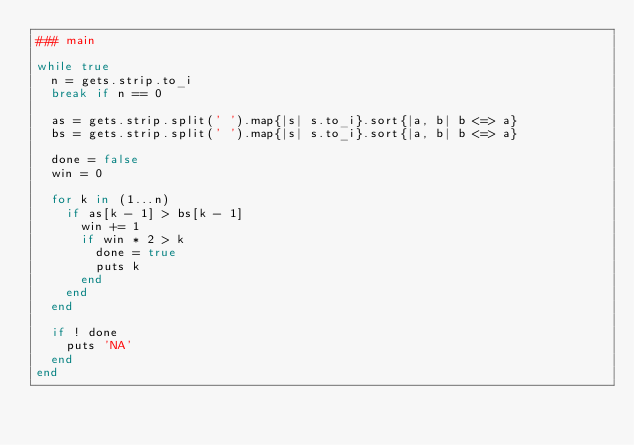<code> <loc_0><loc_0><loc_500><loc_500><_Ruby_>### main

while true
  n = gets.strip.to_i
  break if n == 0

  as = gets.strip.split(' ').map{|s| s.to_i}.sort{|a, b| b <=> a}
  bs = gets.strip.split(' ').map{|s| s.to_i}.sort{|a, b| b <=> a}

  done = false
  win = 0

  for k in (1...n)
    if as[k - 1] > bs[k - 1]
      win += 1
      if win * 2 > k
        done = true
        puts k
      end
    end
  end

  if ! done
    puts 'NA'
  end
end</code> 